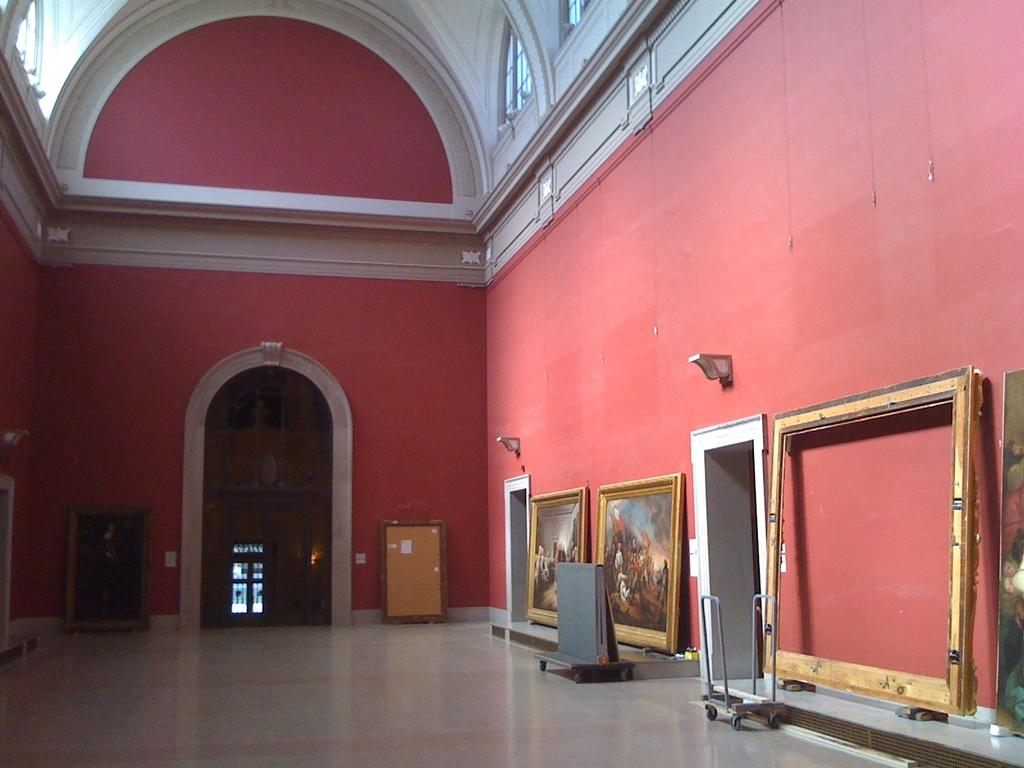What is the main setting of the picture? There is a room in the picture. What can be seen hanging on the walls in the room? There are many frames present in the room. Are there any entrances or exits in the room? Yes, there are doors present in the room. What type of gold material is used to create the frames in the room? There is no mention of gold material being used to create the frames in the image. The frames could be made of various materials, but gold is not specified. 